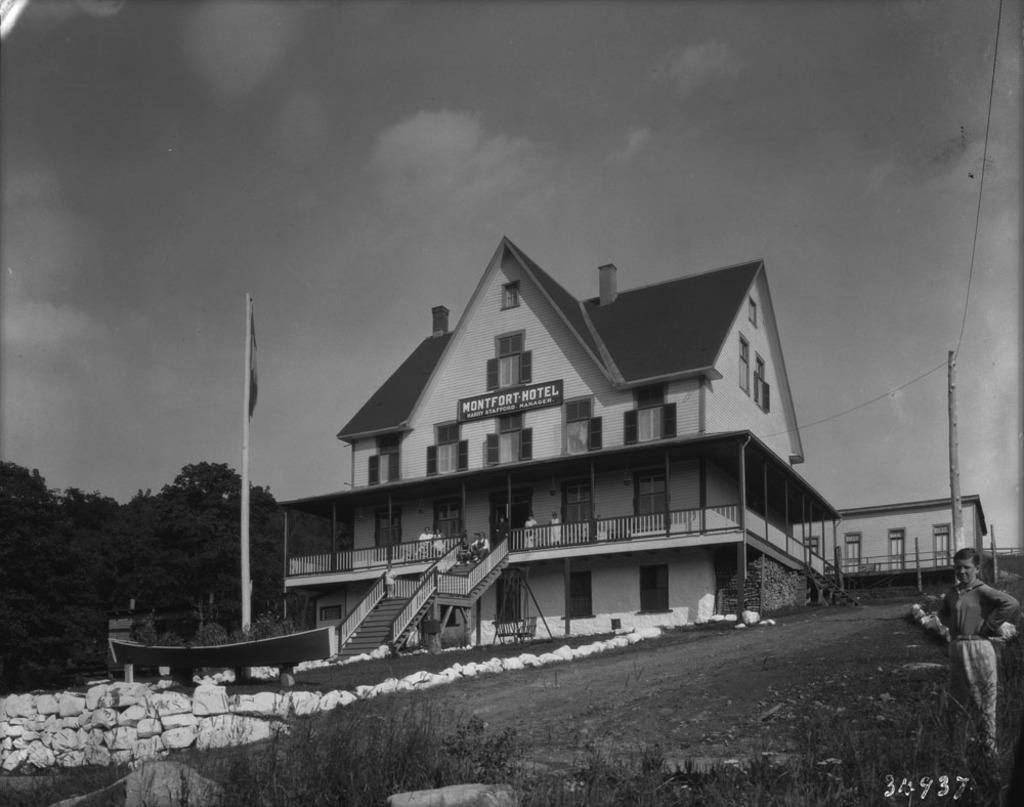Please provide a concise description of this image. This is black and white picture where we can see a house in the middle of the image. Left side of the image one flag and trees are there. Right bottom of the image one person is standing. Behind the person bamboo pole is present with wires attached to it. Top of the image sky is present. Bottom of the image some grass is there. 